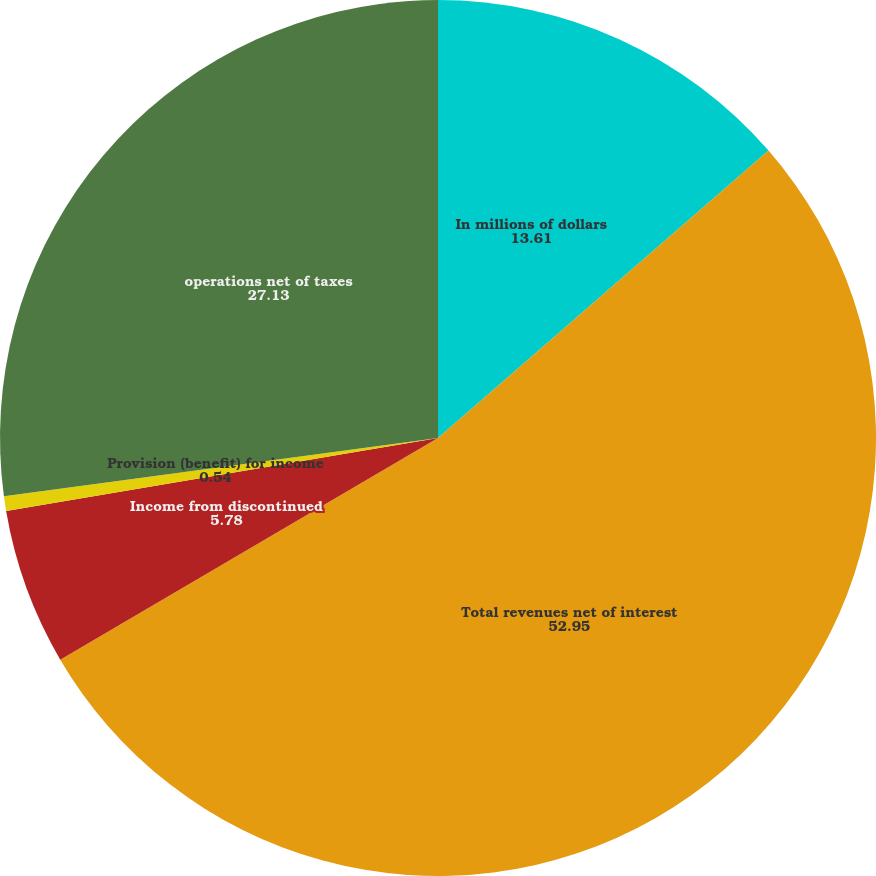Convert chart. <chart><loc_0><loc_0><loc_500><loc_500><pie_chart><fcel>In millions of dollars<fcel>Total revenues net of interest<fcel>Income from discontinued<fcel>Provision (benefit) for income<fcel>operations net of taxes<nl><fcel>13.61%<fcel>52.95%<fcel>5.78%<fcel>0.54%<fcel>27.13%<nl></chart> 